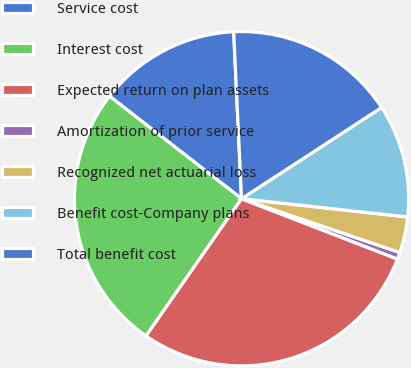<chart> <loc_0><loc_0><loc_500><loc_500><pie_chart><fcel>Service cost<fcel>Interest cost<fcel>Expected return on plan assets<fcel>Amortization of prior service<fcel>Recognized net actuarial loss<fcel>Benefit cost-Company plans<fcel>Total benefit cost<nl><fcel>13.74%<fcel>25.83%<fcel>28.8%<fcel>0.66%<fcel>3.47%<fcel>10.93%<fcel>16.56%<nl></chart> 